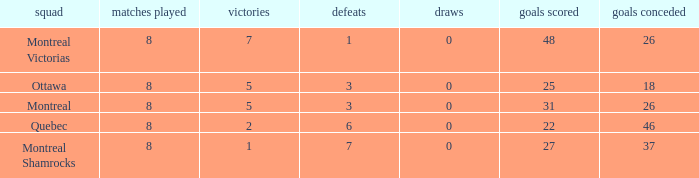For teams with more than 0 ties and goals against of 37, how many wins were tallied? None. 